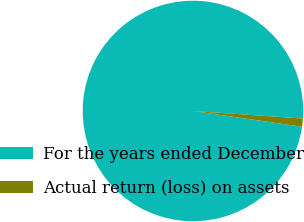Convert chart to OTSL. <chart><loc_0><loc_0><loc_500><loc_500><pie_chart><fcel>For the years ended December<fcel>Actual return (loss) on assets<nl><fcel>98.81%<fcel>1.19%<nl></chart> 